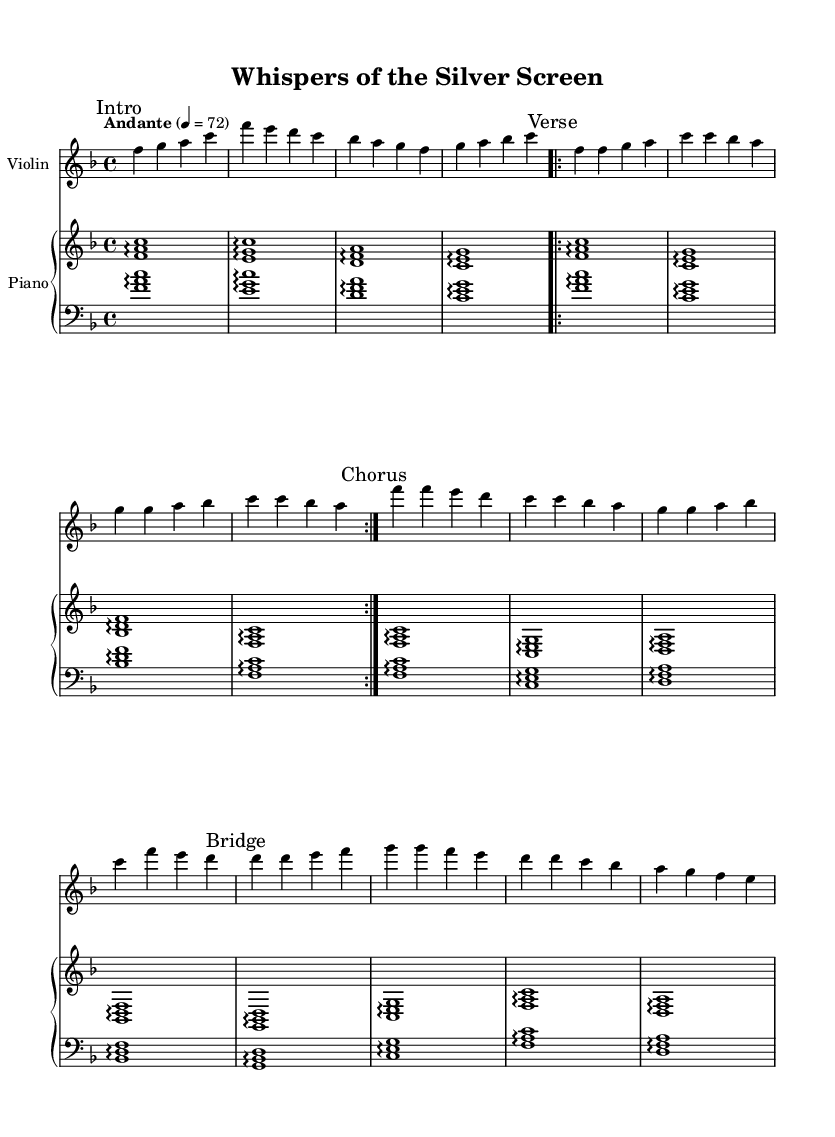What is the key signature of this music? The key signature is indicated at the beginning of the staff. In this piece, there is one flat, which represents B flat. This means that the piece is in F major.
Answer: F major What is the time signature of this music? The time signature is shown at the beginning of the piece. In this score, it states "4/4," indicating that there are four beats in each measure and a quarter note receives one beat.
Answer: 4/4 What is the tempo marking in this music? The tempo marking is placed above the staff and indicates the speed of the piece. Here it is marked "Andante," which is typically interpreted as a moderate pace.
Answer: Andante How many times is the verse repeated? The verse section is marked with a "repeat volta" sign, which instructs the musician to play it twice in total. The repeat markings indicate that the section specifically designated as the verse will be played two times.
Answer: 2 What is the dynamic marking in the violin part? The dynamic marking can be found at the beginning of the violin part, denoted as "dynamicUp," which typically suggests the performer should play with a lively, expressive style. This aspect enhances the emotional expression typical in K-pop ballads.
Answer: DynamicUp What is the primary instrument accompanying the violin? By looking at the structure of the score, the violin part has a piano staff underneath it, indicating that the primary accompaniment for this arrangement is the piano. This is a common practice in orchestral arrangements, especially for ballads.
Answer: Piano In what section does the music transition to a bridge? The transition to the bridge section is marked clearly in the score. The term "Bridge" is indicated above the relevant measures, showing where this contrasting section begins. This is often used in music to create tension or contrast with prior material.
Answer: Bridge 